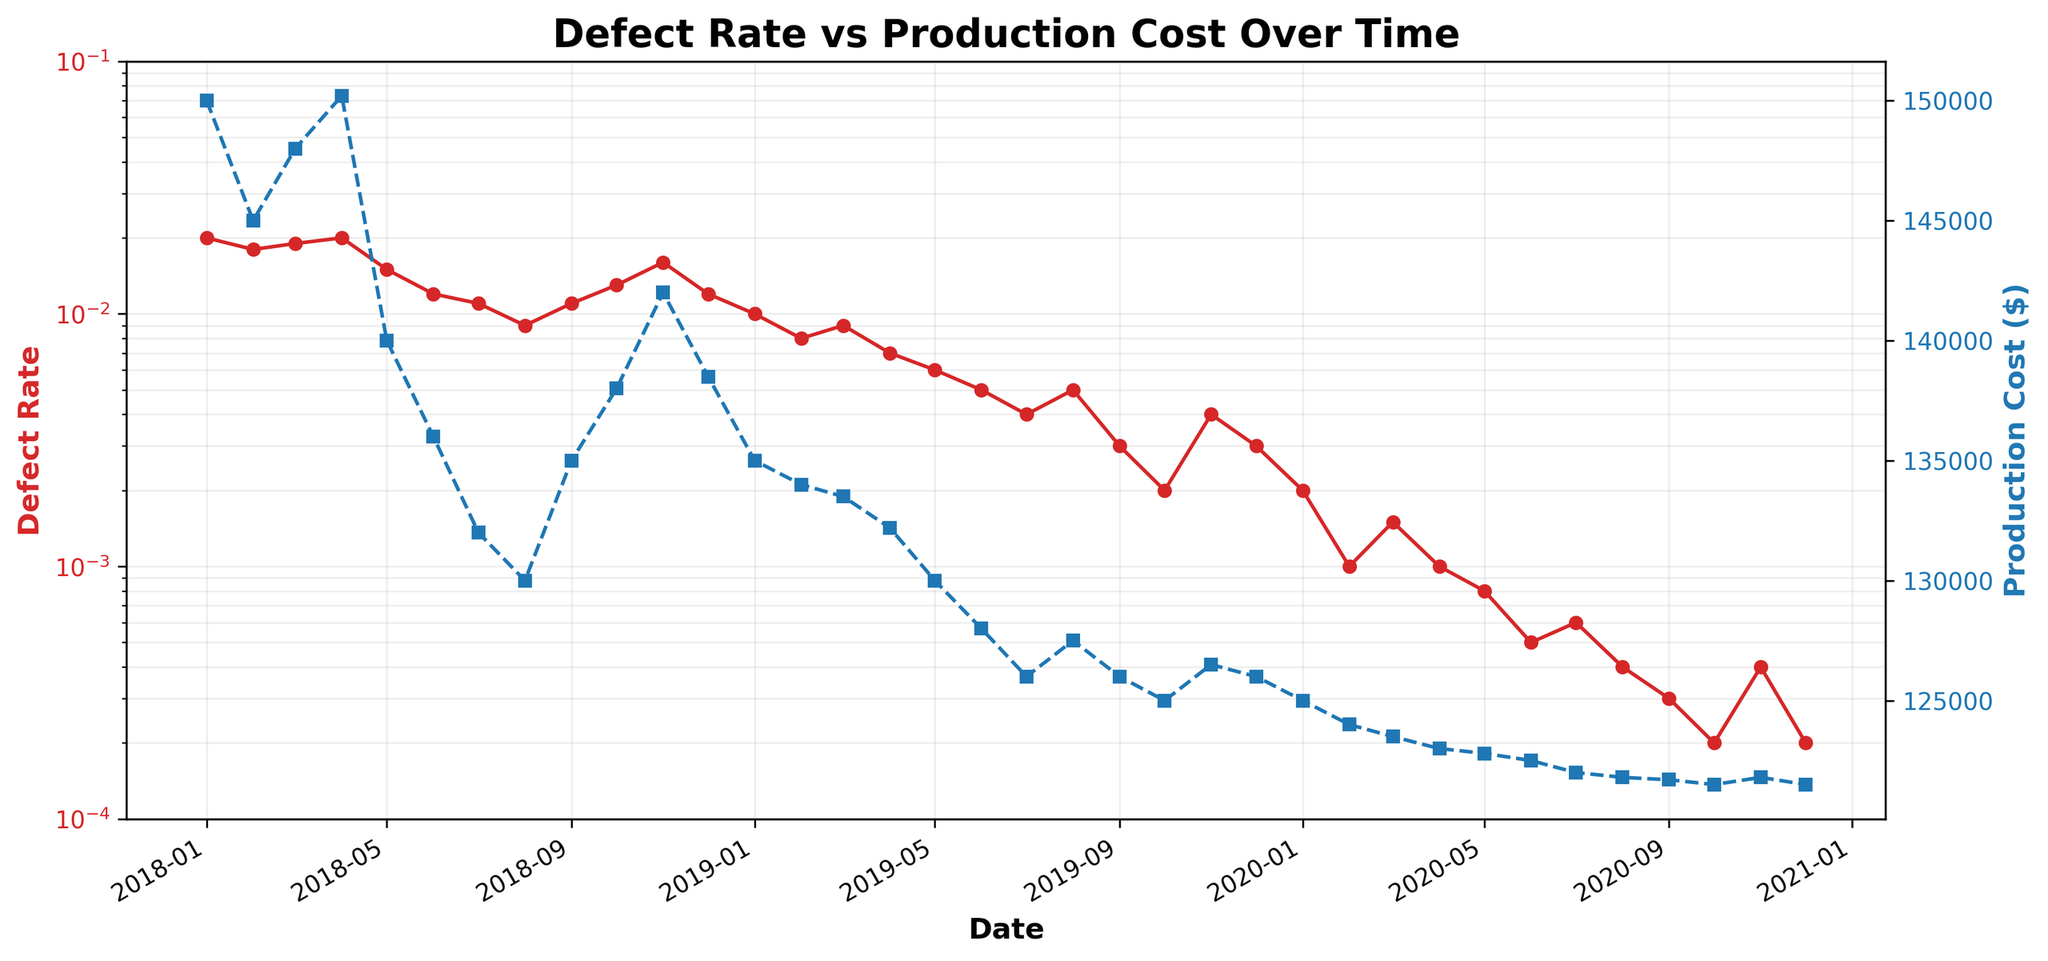What is the title of the plot? The title is always displayed at the top of the plot. In this case, it reads "Defect Rate vs Production Cost Over Time" because it describes the relationship between defect rates and production costs.
Answer: Defect Rate vs Production Cost Over Time What is the general trend in the defect rate over the given time period? Looking at the red line, which represents the defect rate, we observe a general decline from 2018 to 2020. The rate goes down from around 0.02 to about 0.0002.
Answer: Decreasing How do the trends in defect rate and production costs compare? The red line representing the defect rate significantly decreases over time while the blue line representing production costs also shows a decreasing trend but at a much slower rate.
Answer: Both decrease, but defect rate decreases faster What is the defect rate in July 2019? Locate July 2019 on the x-axis and follow the corresponding point on the red line. The defect rate is around 0.004.
Answer: 0.004 How does the production cost in January 2020 compare to December 2020? Locate January and December 2020 on the x-axis and follow the points on the blue line. The production cost is $125,000 in January and remains $121,500 in December.
Answer: Higher in January What was the lowest defect rate recorded and in which month and year did it occur? Find the lowest point on the red line. The smallest defect rate recorded is 0.0002, which occurred in both October and December 2020.
Answer: 0.0002 in October and December 2020 What was the percentage decrease in defect rate from January 2018 to December 2020? Calculate the decrease first: (0.02 - 0.0002) = 0.0198. The percentage decrease is (0.0198/0.02) * 100 = 99%.
Answer: 99% Which year had the highest production cost, and what was the cost? The highest point on the blue line appears at the beginning of the plot, check the y-axis for values in early 2018. The cost was $150,200 which occurred in April 2018.
Answer: 2018, $150,200 